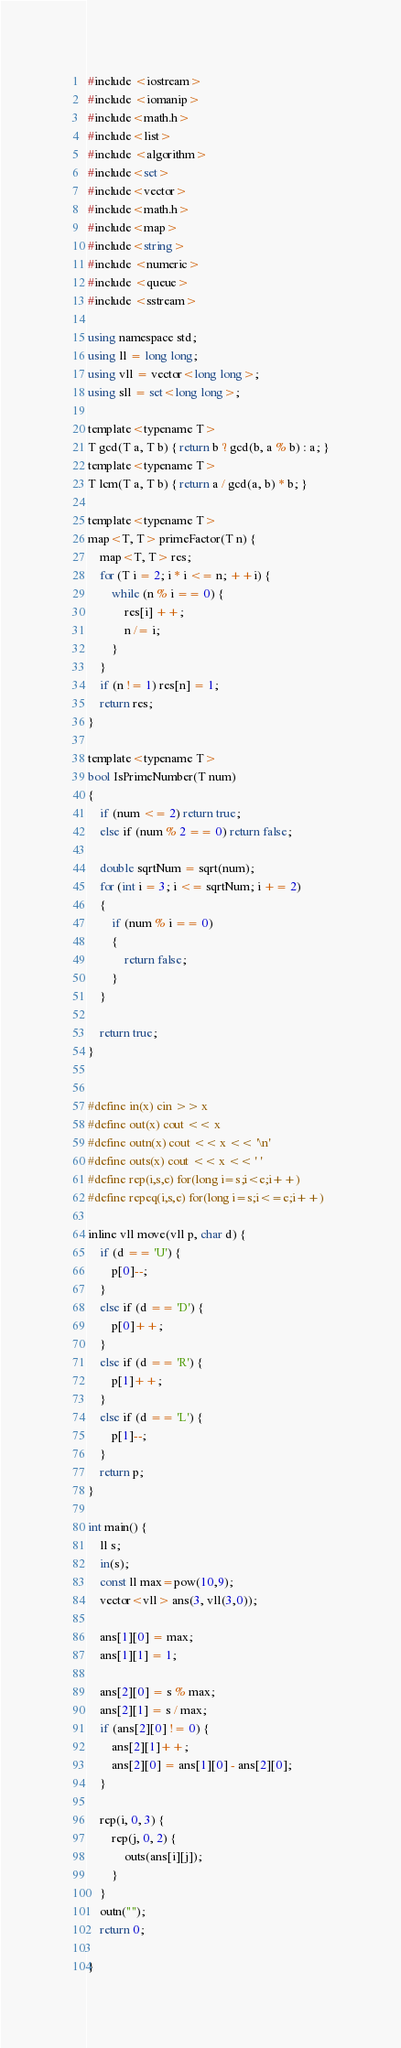Convert code to text. <code><loc_0><loc_0><loc_500><loc_500><_C#_>#include <iostream>
#include <iomanip>
#include<math.h>
#include<list>
#include <algorithm>
#include<set>
#include<vector>
#include<math.h>
#include<map>
#include<string>
#include <numeric>
#include <queue>
#include <sstream>

using namespace std;
using ll = long long;
using vll = vector<long long>;
using sll = set<long long>;

template<typename T>
T gcd(T a, T b) { return b ? gcd(b, a % b) : a; }
template<typename T>
T lcm(T a, T b) { return a / gcd(a, b) * b; }

template<typename T>
map<T, T> primeFactor(T n) {
	map<T, T> res;
	for (T i = 2; i * i <= n; ++i) {
		while (n % i == 0) {
			res[i] ++;
			n /= i;
		}
	}
	if (n != 1) res[n] = 1;
	return res;
}

template<typename T>
bool IsPrimeNumber(T num)
{
	if (num <= 2) return true;
	else if (num % 2 == 0) return false;

	double sqrtNum = sqrt(num);
	for (int i = 3; i <= sqrtNum; i += 2)
	{
		if (num % i == 0)
		{
			return false;
		}
	}

	return true;
}


#define in(x) cin >> x
#define out(x) cout << x
#define outn(x) cout << x << '\n'
#define outs(x) cout << x << ' '
#define rep(i,s,e) for(long i=s;i<e;i++)
#define repeq(i,s,e) for(long i=s;i<=e;i++)

inline vll move(vll p, char d) {
	if (d == 'U') {
		p[0]--;
	}
	else if (d == 'D') {
		p[0]++;
	}
	else if (d == 'R') {
		p[1]++;
	}
	else if (d == 'L') {
		p[1]--;
	}
	return p;
}

int main() {
	ll s;
	in(s);
	const ll max=pow(10,9);
	vector<vll> ans(3, vll(3,0));

	ans[1][0] = max;
	ans[1][1] = 1;

	ans[2][0] = s % max;
	ans[2][1] = s / max;
	if (ans[2][0] != 0) {
		ans[2][1]++;
		ans[2][0] = ans[1][0] - ans[2][0];
	}

	rep(i, 0, 3) {
		rep(j, 0, 2) {
			outs(ans[i][j]);
		}
	}
	outn("");
	return 0;

}
</code> 